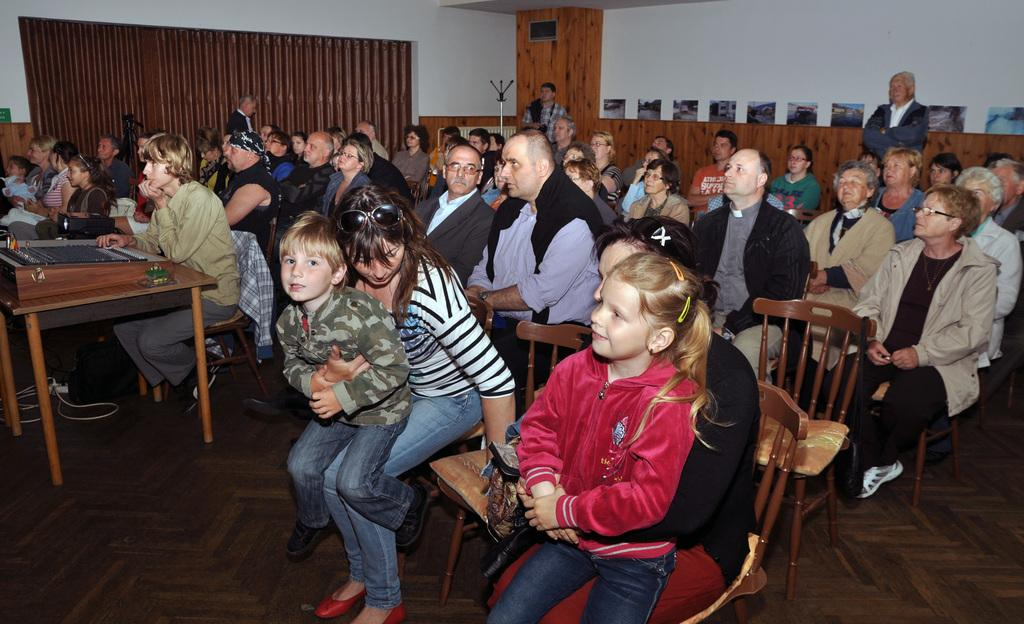Who is present in the image? There are people in the image. What are the people doing in the image? The people are sitting on chairs. What type of ornament is hanging from the basketball hoop in the image? There is no basketball hoop or ornament present in the image. 